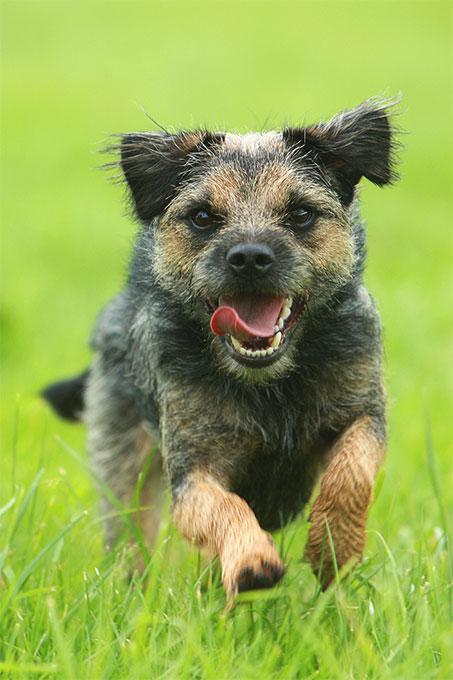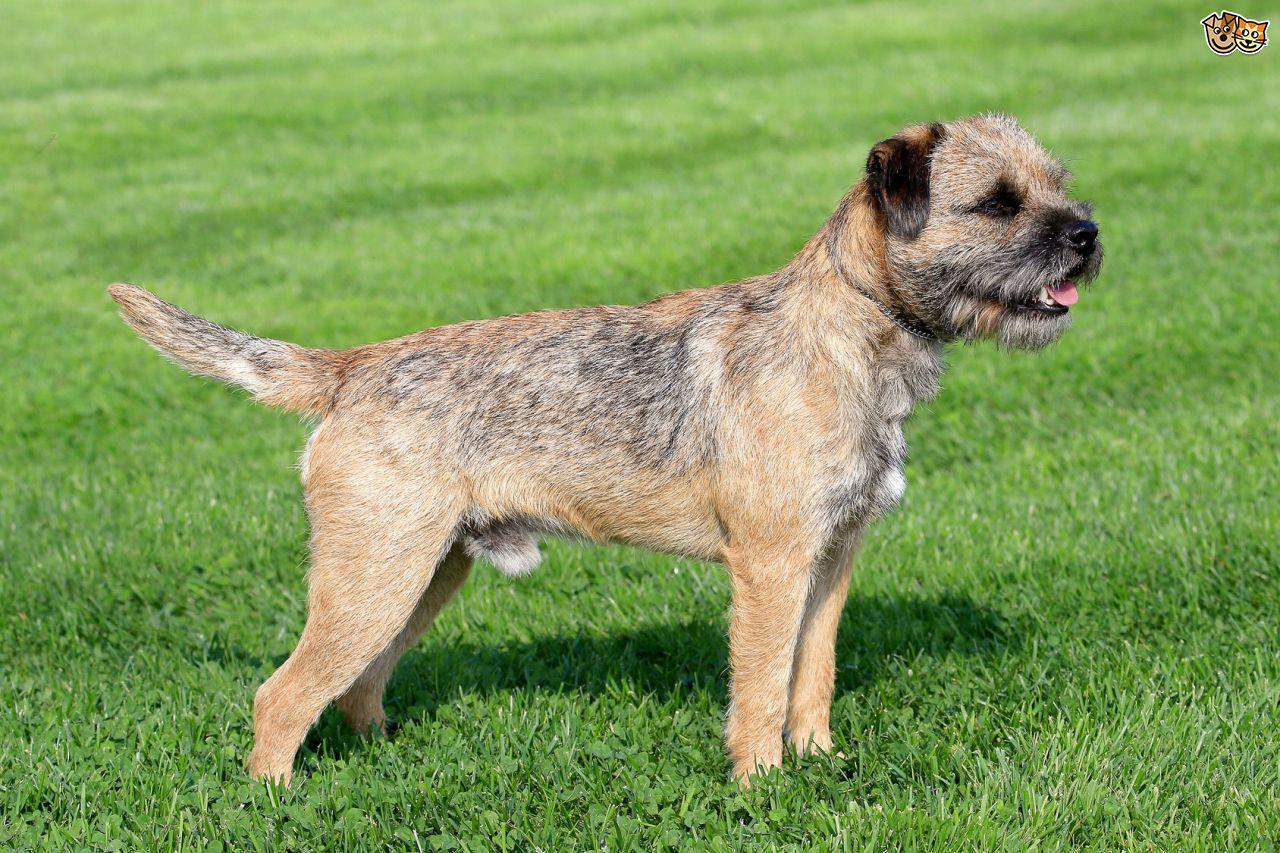The first image is the image on the left, the second image is the image on the right. Evaluate the accuracy of this statement regarding the images: "The animal in one of the images is on all fours and facing right". Is it true? Answer yes or no. Yes. The first image is the image on the left, the second image is the image on the right. Given the left and right images, does the statement "Right image shows a dog standing in profile on grass." hold true? Answer yes or no. Yes. 